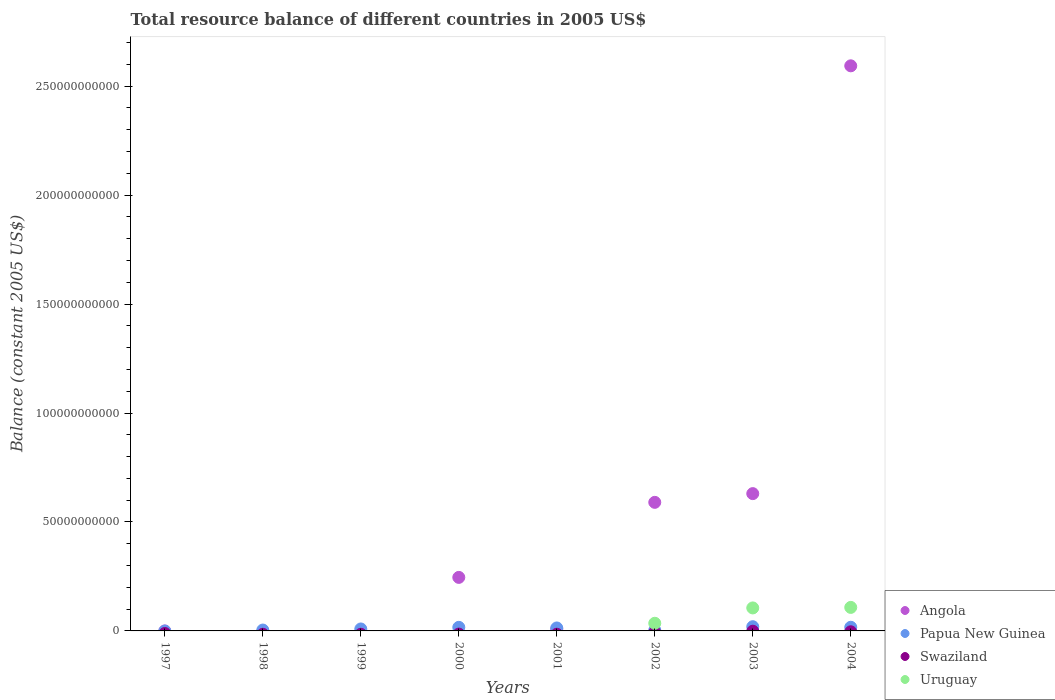How many different coloured dotlines are there?
Provide a succinct answer. 3. What is the total resource balance in Swaziland in 1998?
Provide a succinct answer. 0. Across all years, what is the maximum total resource balance in Angola?
Offer a terse response. 2.59e+11. In which year was the total resource balance in Angola maximum?
Give a very brief answer. 2004. What is the total total resource balance in Papua New Guinea in the graph?
Ensure brevity in your answer.  8.27e+09. What is the difference between the total resource balance in Papua New Guinea in 1998 and that in 2001?
Offer a terse response. -9.52e+08. What is the difference between the total resource balance in Papua New Guinea in 1998 and the total resource balance in Angola in 2002?
Provide a succinct answer. -5.86e+1. What is the average total resource balance in Papua New Guinea per year?
Offer a terse response. 1.03e+09. In the year 2000, what is the difference between the total resource balance in Papua New Guinea and total resource balance in Angola?
Make the answer very short. -2.29e+1. What is the ratio of the total resource balance in Angola in 2000 to that in 2004?
Give a very brief answer. 0.09. What is the difference between the highest and the second highest total resource balance in Papua New Guinea?
Offer a terse response. 2.58e+08. What is the difference between the highest and the lowest total resource balance in Uruguay?
Give a very brief answer. 1.08e+1. In how many years, is the total resource balance in Angola greater than the average total resource balance in Angola taken over all years?
Make the answer very short. 3. Is it the case that in every year, the sum of the total resource balance in Papua New Guinea and total resource balance in Uruguay  is greater than the sum of total resource balance in Swaziland and total resource balance in Angola?
Offer a very short reply. No. Does the total resource balance in Swaziland monotonically increase over the years?
Offer a terse response. No. Does the graph contain grids?
Your response must be concise. No. Where does the legend appear in the graph?
Make the answer very short. Bottom right. How many legend labels are there?
Offer a terse response. 4. How are the legend labels stacked?
Offer a terse response. Vertical. What is the title of the graph?
Keep it short and to the point. Total resource balance of different countries in 2005 US$. What is the label or title of the X-axis?
Keep it short and to the point. Years. What is the label or title of the Y-axis?
Your response must be concise. Balance (constant 2005 US$). What is the Balance (constant 2005 US$) in Angola in 1998?
Offer a terse response. 0. What is the Balance (constant 2005 US$) of Papua New Guinea in 1998?
Your response must be concise. 4.08e+08. What is the Balance (constant 2005 US$) in Angola in 1999?
Offer a very short reply. 0. What is the Balance (constant 2005 US$) in Papua New Guinea in 1999?
Offer a terse response. 9.03e+08. What is the Balance (constant 2005 US$) of Uruguay in 1999?
Your answer should be very brief. 0. What is the Balance (constant 2005 US$) of Angola in 2000?
Make the answer very short. 2.46e+1. What is the Balance (constant 2005 US$) of Papua New Guinea in 2000?
Offer a terse response. 1.65e+09. What is the Balance (constant 2005 US$) in Uruguay in 2000?
Your answer should be compact. 0. What is the Balance (constant 2005 US$) of Angola in 2001?
Keep it short and to the point. 8.72e+08. What is the Balance (constant 2005 US$) in Papua New Guinea in 2001?
Your response must be concise. 1.36e+09. What is the Balance (constant 2005 US$) of Swaziland in 2001?
Offer a very short reply. 0. What is the Balance (constant 2005 US$) in Angola in 2002?
Ensure brevity in your answer.  5.90e+1. What is the Balance (constant 2005 US$) of Papua New Guinea in 2002?
Make the answer very short. 3.39e+08. What is the Balance (constant 2005 US$) in Swaziland in 2002?
Offer a terse response. 0. What is the Balance (constant 2005 US$) of Uruguay in 2002?
Offer a very short reply. 3.51e+09. What is the Balance (constant 2005 US$) of Angola in 2003?
Ensure brevity in your answer.  6.30e+1. What is the Balance (constant 2005 US$) in Papua New Guinea in 2003?
Provide a short and direct response. 1.93e+09. What is the Balance (constant 2005 US$) of Uruguay in 2003?
Provide a short and direct response. 1.06e+1. What is the Balance (constant 2005 US$) in Angola in 2004?
Provide a short and direct response. 2.59e+11. What is the Balance (constant 2005 US$) of Papua New Guinea in 2004?
Your answer should be compact. 1.68e+09. What is the Balance (constant 2005 US$) in Uruguay in 2004?
Provide a succinct answer. 1.08e+1. Across all years, what is the maximum Balance (constant 2005 US$) of Angola?
Offer a terse response. 2.59e+11. Across all years, what is the maximum Balance (constant 2005 US$) of Papua New Guinea?
Your answer should be very brief. 1.93e+09. Across all years, what is the maximum Balance (constant 2005 US$) in Uruguay?
Your answer should be very brief. 1.08e+1. Across all years, what is the minimum Balance (constant 2005 US$) of Papua New Guinea?
Offer a terse response. 0. Across all years, what is the minimum Balance (constant 2005 US$) of Uruguay?
Make the answer very short. 0. What is the total Balance (constant 2005 US$) in Angola in the graph?
Provide a short and direct response. 4.07e+11. What is the total Balance (constant 2005 US$) of Papua New Guinea in the graph?
Offer a very short reply. 8.27e+09. What is the total Balance (constant 2005 US$) of Uruguay in the graph?
Keep it short and to the point. 2.49e+1. What is the difference between the Balance (constant 2005 US$) in Papua New Guinea in 1998 and that in 1999?
Your response must be concise. -4.96e+08. What is the difference between the Balance (constant 2005 US$) of Papua New Guinea in 1998 and that in 2000?
Offer a very short reply. -1.24e+09. What is the difference between the Balance (constant 2005 US$) of Papua New Guinea in 1998 and that in 2001?
Your answer should be compact. -9.52e+08. What is the difference between the Balance (constant 2005 US$) in Papua New Guinea in 1998 and that in 2002?
Offer a very short reply. 6.80e+07. What is the difference between the Balance (constant 2005 US$) of Papua New Guinea in 1998 and that in 2003?
Offer a very short reply. -1.53e+09. What is the difference between the Balance (constant 2005 US$) in Papua New Guinea in 1998 and that in 2004?
Ensure brevity in your answer.  -1.27e+09. What is the difference between the Balance (constant 2005 US$) in Papua New Guinea in 1999 and that in 2000?
Give a very brief answer. -7.46e+08. What is the difference between the Balance (constant 2005 US$) in Papua New Guinea in 1999 and that in 2001?
Your answer should be compact. -4.57e+08. What is the difference between the Balance (constant 2005 US$) of Papua New Guinea in 1999 and that in 2002?
Your response must be concise. 5.64e+08. What is the difference between the Balance (constant 2005 US$) in Papua New Guinea in 1999 and that in 2003?
Give a very brief answer. -1.03e+09. What is the difference between the Balance (constant 2005 US$) in Papua New Guinea in 1999 and that in 2004?
Provide a short and direct response. -7.73e+08. What is the difference between the Balance (constant 2005 US$) of Angola in 2000 and that in 2001?
Offer a very short reply. 2.37e+1. What is the difference between the Balance (constant 2005 US$) of Papua New Guinea in 2000 and that in 2001?
Provide a succinct answer. 2.89e+08. What is the difference between the Balance (constant 2005 US$) in Angola in 2000 and that in 2002?
Provide a short and direct response. -3.44e+1. What is the difference between the Balance (constant 2005 US$) in Papua New Guinea in 2000 and that in 2002?
Make the answer very short. 1.31e+09. What is the difference between the Balance (constant 2005 US$) in Angola in 2000 and that in 2003?
Make the answer very short. -3.84e+1. What is the difference between the Balance (constant 2005 US$) of Papua New Guinea in 2000 and that in 2003?
Offer a terse response. -2.85e+08. What is the difference between the Balance (constant 2005 US$) of Angola in 2000 and that in 2004?
Your answer should be compact. -2.35e+11. What is the difference between the Balance (constant 2005 US$) in Papua New Guinea in 2000 and that in 2004?
Your response must be concise. -2.71e+07. What is the difference between the Balance (constant 2005 US$) of Angola in 2001 and that in 2002?
Make the answer very short. -5.81e+1. What is the difference between the Balance (constant 2005 US$) in Papua New Guinea in 2001 and that in 2002?
Give a very brief answer. 1.02e+09. What is the difference between the Balance (constant 2005 US$) in Angola in 2001 and that in 2003?
Your answer should be very brief. -6.21e+1. What is the difference between the Balance (constant 2005 US$) of Papua New Guinea in 2001 and that in 2003?
Make the answer very short. -5.74e+08. What is the difference between the Balance (constant 2005 US$) of Angola in 2001 and that in 2004?
Give a very brief answer. -2.58e+11. What is the difference between the Balance (constant 2005 US$) in Papua New Guinea in 2001 and that in 2004?
Make the answer very short. -3.16e+08. What is the difference between the Balance (constant 2005 US$) of Angola in 2002 and that in 2003?
Give a very brief answer. -4.00e+09. What is the difference between the Balance (constant 2005 US$) of Papua New Guinea in 2002 and that in 2003?
Ensure brevity in your answer.  -1.59e+09. What is the difference between the Balance (constant 2005 US$) in Uruguay in 2002 and that in 2003?
Offer a terse response. -7.04e+09. What is the difference between the Balance (constant 2005 US$) of Angola in 2002 and that in 2004?
Keep it short and to the point. -2.00e+11. What is the difference between the Balance (constant 2005 US$) of Papua New Guinea in 2002 and that in 2004?
Keep it short and to the point. -1.34e+09. What is the difference between the Balance (constant 2005 US$) of Uruguay in 2002 and that in 2004?
Give a very brief answer. -7.28e+09. What is the difference between the Balance (constant 2005 US$) in Angola in 2003 and that in 2004?
Make the answer very short. -1.96e+11. What is the difference between the Balance (constant 2005 US$) in Papua New Guinea in 2003 and that in 2004?
Your answer should be compact. 2.58e+08. What is the difference between the Balance (constant 2005 US$) in Uruguay in 2003 and that in 2004?
Offer a terse response. -2.42e+08. What is the difference between the Balance (constant 2005 US$) of Papua New Guinea in 1998 and the Balance (constant 2005 US$) of Uruguay in 2002?
Give a very brief answer. -3.10e+09. What is the difference between the Balance (constant 2005 US$) in Papua New Guinea in 1998 and the Balance (constant 2005 US$) in Uruguay in 2003?
Give a very brief answer. -1.01e+1. What is the difference between the Balance (constant 2005 US$) of Papua New Guinea in 1998 and the Balance (constant 2005 US$) of Uruguay in 2004?
Provide a succinct answer. -1.04e+1. What is the difference between the Balance (constant 2005 US$) in Papua New Guinea in 1999 and the Balance (constant 2005 US$) in Uruguay in 2002?
Ensure brevity in your answer.  -2.61e+09. What is the difference between the Balance (constant 2005 US$) in Papua New Guinea in 1999 and the Balance (constant 2005 US$) in Uruguay in 2003?
Keep it short and to the point. -9.65e+09. What is the difference between the Balance (constant 2005 US$) in Papua New Guinea in 1999 and the Balance (constant 2005 US$) in Uruguay in 2004?
Provide a succinct answer. -9.89e+09. What is the difference between the Balance (constant 2005 US$) in Angola in 2000 and the Balance (constant 2005 US$) in Papua New Guinea in 2001?
Ensure brevity in your answer.  2.32e+1. What is the difference between the Balance (constant 2005 US$) in Angola in 2000 and the Balance (constant 2005 US$) in Papua New Guinea in 2002?
Provide a succinct answer. 2.42e+1. What is the difference between the Balance (constant 2005 US$) of Angola in 2000 and the Balance (constant 2005 US$) of Uruguay in 2002?
Keep it short and to the point. 2.11e+1. What is the difference between the Balance (constant 2005 US$) in Papua New Guinea in 2000 and the Balance (constant 2005 US$) in Uruguay in 2002?
Provide a short and direct response. -1.86e+09. What is the difference between the Balance (constant 2005 US$) of Angola in 2000 and the Balance (constant 2005 US$) of Papua New Guinea in 2003?
Your answer should be very brief. 2.26e+1. What is the difference between the Balance (constant 2005 US$) of Angola in 2000 and the Balance (constant 2005 US$) of Uruguay in 2003?
Keep it short and to the point. 1.40e+1. What is the difference between the Balance (constant 2005 US$) in Papua New Guinea in 2000 and the Balance (constant 2005 US$) in Uruguay in 2003?
Your answer should be compact. -8.90e+09. What is the difference between the Balance (constant 2005 US$) in Angola in 2000 and the Balance (constant 2005 US$) in Papua New Guinea in 2004?
Provide a succinct answer. 2.29e+1. What is the difference between the Balance (constant 2005 US$) of Angola in 2000 and the Balance (constant 2005 US$) of Uruguay in 2004?
Ensure brevity in your answer.  1.38e+1. What is the difference between the Balance (constant 2005 US$) of Papua New Guinea in 2000 and the Balance (constant 2005 US$) of Uruguay in 2004?
Your response must be concise. -9.15e+09. What is the difference between the Balance (constant 2005 US$) in Angola in 2001 and the Balance (constant 2005 US$) in Papua New Guinea in 2002?
Provide a short and direct response. 5.33e+08. What is the difference between the Balance (constant 2005 US$) in Angola in 2001 and the Balance (constant 2005 US$) in Uruguay in 2002?
Offer a very short reply. -2.64e+09. What is the difference between the Balance (constant 2005 US$) in Papua New Guinea in 2001 and the Balance (constant 2005 US$) in Uruguay in 2002?
Keep it short and to the point. -2.15e+09. What is the difference between the Balance (constant 2005 US$) in Angola in 2001 and the Balance (constant 2005 US$) in Papua New Guinea in 2003?
Offer a terse response. -1.06e+09. What is the difference between the Balance (constant 2005 US$) in Angola in 2001 and the Balance (constant 2005 US$) in Uruguay in 2003?
Your answer should be compact. -9.68e+09. What is the difference between the Balance (constant 2005 US$) in Papua New Guinea in 2001 and the Balance (constant 2005 US$) in Uruguay in 2003?
Your answer should be very brief. -9.19e+09. What is the difference between the Balance (constant 2005 US$) in Angola in 2001 and the Balance (constant 2005 US$) in Papua New Guinea in 2004?
Your answer should be very brief. -8.04e+08. What is the difference between the Balance (constant 2005 US$) of Angola in 2001 and the Balance (constant 2005 US$) of Uruguay in 2004?
Make the answer very short. -9.92e+09. What is the difference between the Balance (constant 2005 US$) of Papua New Guinea in 2001 and the Balance (constant 2005 US$) of Uruguay in 2004?
Your answer should be compact. -9.44e+09. What is the difference between the Balance (constant 2005 US$) in Angola in 2002 and the Balance (constant 2005 US$) in Papua New Guinea in 2003?
Your response must be concise. 5.71e+1. What is the difference between the Balance (constant 2005 US$) in Angola in 2002 and the Balance (constant 2005 US$) in Uruguay in 2003?
Offer a terse response. 4.85e+1. What is the difference between the Balance (constant 2005 US$) of Papua New Guinea in 2002 and the Balance (constant 2005 US$) of Uruguay in 2003?
Give a very brief answer. -1.02e+1. What is the difference between the Balance (constant 2005 US$) in Angola in 2002 and the Balance (constant 2005 US$) in Papua New Guinea in 2004?
Keep it short and to the point. 5.73e+1. What is the difference between the Balance (constant 2005 US$) of Angola in 2002 and the Balance (constant 2005 US$) of Uruguay in 2004?
Keep it short and to the point. 4.82e+1. What is the difference between the Balance (constant 2005 US$) in Papua New Guinea in 2002 and the Balance (constant 2005 US$) in Uruguay in 2004?
Make the answer very short. -1.05e+1. What is the difference between the Balance (constant 2005 US$) in Angola in 2003 and the Balance (constant 2005 US$) in Papua New Guinea in 2004?
Provide a short and direct response. 6.13e+1. What is the difference between the Balance (constant 2005 US$) in Angola in 2003 and the Balance (constant 2005 US$) in Uruguay in 2004?
Your answer should be very brief. 5.22e+1. What is the difference between the Balance (constant 2005 US$) of Papua New Guinea in 2003 and the Balance (constant 2005 US$) of Uruguay in 2004?
Make the answer very short. -8.86e+09. What is the average Balance (constant 2005 US$) of Angola per year?
Provide a short and direct response. 5.08e+1. What is the average Balance (constant 2005 US$) in Papua New Guinea per year?
Your answer should be compact. 1.03e+09. What is the average Balance (constant 2005 US$) in Swaziland per year?
Keep it short and to the point. 0. What is the average Balance (constant 2005 US$) of Uruguay per year?
Make the answer very short. 3.11e+09. In the year 2000, what is the difference between the Balance (constant 2005 US$) of Angola and Balance (constant 2005 US$) of Papua New Guinea?
Provide a short and direct response. 2.29e+1. In the year 2001, what is the difference between the Balance (constant 2005 US$) in Angola and Balance (constant 2005 US$) in Papua New Guinea?
Your answer should be compact. -4.88e+08. In the year 2002, what is the difference between the Balance (constant 2005 US$) of Angola and Balance (constant 2005 US$) of Papua New Guinea?
Your answer should be compact. 5.87e+1. In the year 2002, what is the difference between the Balance (constant 2005 US$) of Angola and Balance (constant 2005 US$) of Uruguay?
Your response must be concise. 5.55e+1. In the year 2002, what is the difference between the Balance (constant 2005 US$) of Papua New Guinea and Balance (constant 2005 US$) of Uruguay?
Make the answer very short. -3.17e+09. In the year 2003, what is the difference between the Balance (constant 2005 US$) of Angola and Balance (constant 2005 US$) of Papua New Guinea?
Offer a very short reply. 6.11e+1. In the year 2003, what is the difference between the Balance (constant 2005 US$) of Angola and Balance (constant 2005 US$) of Uruguay?
Keep it short and to the point. 5.25e+1. In the year 2003, what is the difference between the Balance (constant 2005 US$) in Papua New Guinea and Balance (constant 2005 US$) in Uruguay?
Provide a short and direct response. -8.62e+09. In the year 2004, what is the difference between the Balance (constant 2005 US$) in Angola and Balance (constant 2005 US$) in Papua New Guinea?
Ensure brevity in your answer.  2.58e+11. In the year 2004, what is the difference between the Balance (constant 2005 US$) in Angola and Balance (constant 2005 US$) in Uruguay?
Your answer should be compact. 2.49e+11. In the year 2004, what is the difference between the Balance (constant 2005 US$) in Papua New Guinea and Balance (constant 2005 US$) in Uruguay?
Your answer should be very brief. -9.12e+09. What is the ratio of the Balance (constant 2005 US$) of Papua New Guinea in 1998 to that in 1999?
Your answer should be compact. 0.45. What is the ratio of the Balance (constant 2005 US$) of Papua New Guinea in 1998 to that in 2000?
Keep it short and to the point. 0.25. What is the ratio of the Balance (constant 2005 US$) of Papua New Guinea in 1998 to that in 2001?
Ensure brevity in your answer.  0.3. What is the ratio of the Balance (constant 2005 US$) of Papua New Guinea in 1998 to that in 2002?
Keep it short and to the point. 1.2. What is the ratio of the Balance (constant 2005 US$) in Papua New Guinea in 1998 to that in 2003?
Your answer should be very brief. 0.21. What is the ratio of the Balance (constant 2005 US$) of Papua New Guinea in 1998 to that in 2004?
Provide a short and direct response. 0.24. What is the ratio of the Balance (constant 2005 US$) of Papua New Guinea in 1999 to that in 2000?
Give a very brief answer. 0.55. What is the ratio of the Balance (constant 2005 US$) in Papua New Guinea in 1999 to that in 2001?
Offer a terse response. 0.66. What is the ratio of the Balance (constant 2005 US$) in Papua New Guinea in 1999 to that in 2002?
Give a very brief answer. 2.66. What is the ratio of the Balance (constant 2005 US$) of Papua New Guinea in 1999 to that in 2003?
Give a very brief answer. 0.47. What is the ratio of the Balance (constant 2005 US$) in Papua New Guinea in 1999 to that in 2004?
Offer a very short reply. 0.54. What is the ratio of the Balance (constant 2005 US$) of Angola in 2000 to that in 2001?
Provide a short and direct response. 28.17. What is the ratio of the Balance (constant 2005 US$) in Papua New Guinea in 2000 to that in 2001?
Offer a terse response. 1.21. What is the ratio of the Balance (constant 2005 US$) in Angola in 2000 to that in 2002?
Ensure brevity in your answer.  0.42. What is the ratio of the Balance (constant 2005 US$) of Papua New Guinea in 2000 to that in 2002?
Offer a very short reply. 4.86. What is the ratio of the Balance (constant 2005 US$) in Angola in 2000 to that in 2003?
Provide a succinct answer. 0.39. What is the ratio of the Balance (constant 2005 US$) of Papua New Guinea in 2000 to that in 2003?
Your answer should be very brief. 0.85. What is the ratio of the Balance (constant 2005 US$) of Angola in 2000 to that in 2004?
Provide a short and direct response. 0.09. What is the ratio of the Balance (constant 2005 US$) of Papua New Guinea in 2000 to that in 2004?
Offer a terse response. 0.98. What is the ratio of the Balance (constant 2005 US$) in Angola in 2001 to that in 2002?
Your answer should be very brief. 0.01. What is the ratio of the Balance (constant 2005 US$) of Papua New Guinea in 2001 to that in 2002?
Provide a short and direct response. 4.01. What is the ratio of the Balance (constant 2005 US$) of Angola in 2001 to that in 2003?
Provide a short and direct response. 0.01. What is the ratio of the Balance (constant 2005 US$) in Papua New Guinea in 2001 to that in 2003?
Keep it short and to the point. 0.7. What is the ratio of the Balance (constant 2005 US$) of Angola in 2001 to that in 2004?
Provide a short and direct response. 0. What is the ratio of the Balance (constant 2005 US$) in Papua New Guinea in 2001 to that in 2004?
Make the answer very short. 0.81. What is the ratio of the Balance (constant 2005 US$) in Angola in 2002 to that in 2003?
Ensure brevity in your answer.  0.94. What is the ratio of the Balance (constant 2005 US$) in Papua New Guinea in 2002 to that in 2003?
Give a very brief answer. 0.18. What is the ratio of the Balance (constant 2005 US$) of Uruguay in 2002 to that in 2003?
Keep it short and to the point. 0.33. What is the ratio of the Balance (constant 2005 US$) of Angola in 2002 to that in 2004?
Offer a very short reply. 0.23. What is the ratio of the Balance (constant 2005 US$) of Papua New Guinea in 2002 to that in 2004?
Your answer should be compact. 0.2. What is the ratio of the Balance (constant 2005 US$) of Uruguay in 2002 to that in 2004?
Offer a very short reply. 0.33. What is the ratio of the Balance (constant 2005 US$) of Angola in 2003 to that in 2004?
Your answer should be compact. 0.24. What is the ratio of the Balance (constant 2005 US$) in Papua New Guinea in 2003 to that in 2004?
Offer a very short reply. 1.15. What is the ratio of the Balance (constant 2005 US$) of Uruguay in 2003 to that in 2004?
Provide a succinct answer. 0.98. What is the difference between the highest and the second highest Balance (constant 2005 US$) in Angola?
Your answer should be compact. 1.96e+11. What is the difference between the highest and the second highest Balance (constant 2005 US$) of Papua New Guinea?
Your answer should be very brief. 2.58e+08. What is the difference between the highest and the second highest Balance (constant 2005 US$) in Uruguay?
Give a very brief answer. 2.42e+08. What is the difference between the highest and the lowest Balance (constant 2005 US$) of Angola?
Keep it short and to the point. 2.59e+11. What is the difference between the highest and the lowest Balance (constant 2005 US$) in Papua New Guinea?
Your response must be concise. 1.93e+09. What is the difference between the highest and the lowest Balance (constant 2005 US$) of Uruguay?
Give a very brief answer. 1.08e+1. 